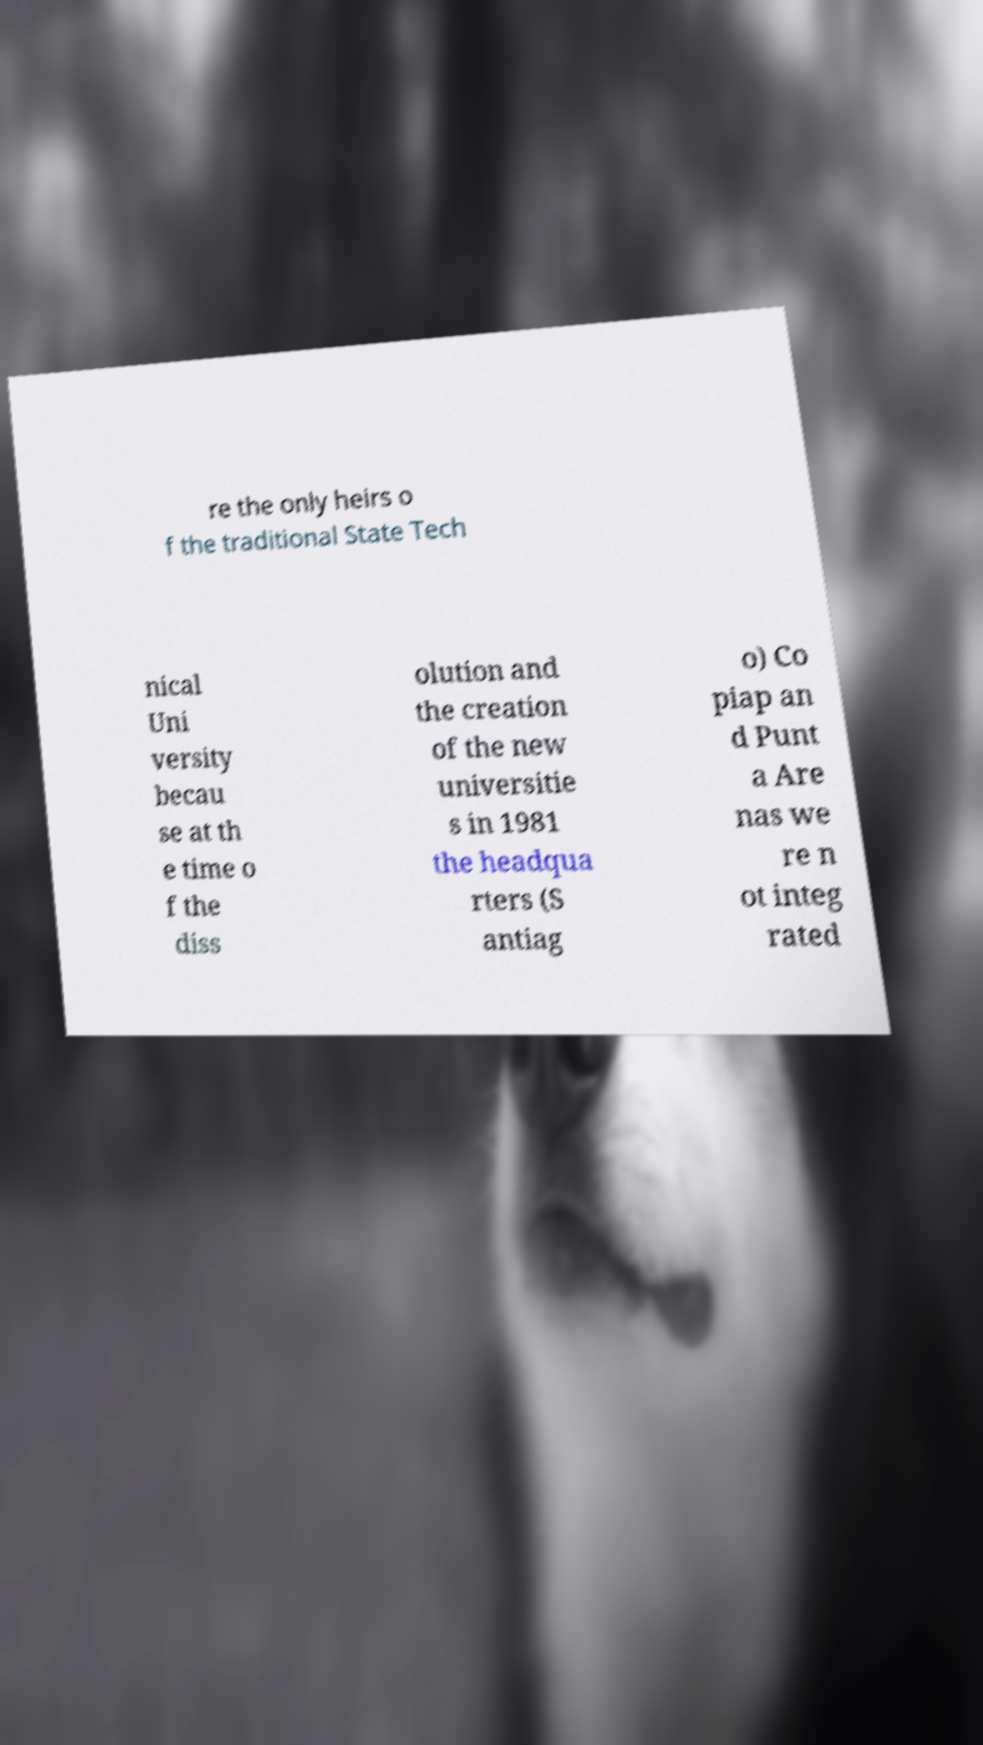Please identify and transcribe the text found in this image. re the only heirs o f the traditional State Tech nical Uni versity becau se at th e time o f the diss olution and the creation of the new universitie s in 1981 the headqua rters (S antiag o) Co piap an d Punt a Are nas we re n ot integ rated 